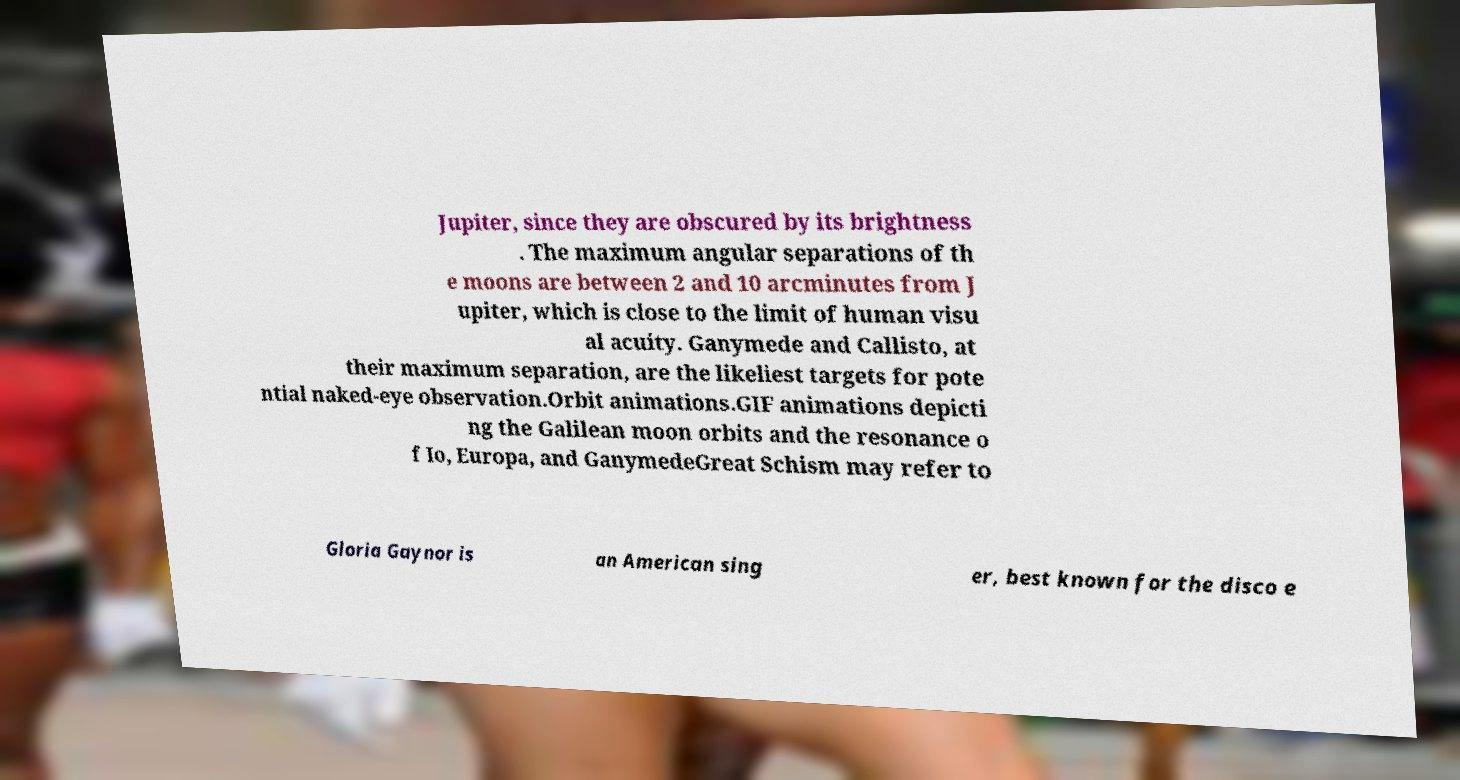What messages or text are displayed in this image? I need them in a readable, typed format. Jupiter, since they are obscured by its brightness . The maximum angular separations of th e moons are between 2 and 10 arcminutes from J upiter, which is close to the limit of human visu al acuity. Ganymede and Callisto, at their maximum separation, are the likeliest targets for pote ntial naked-eye observation.Orbit animations.GIF animations depicti ng the Galilean moon orbits and the resonance o f Io, Europa, and GanymedeGreat Schism may refer to Gloria Gaynor is an American sing er, best known for the disco e 